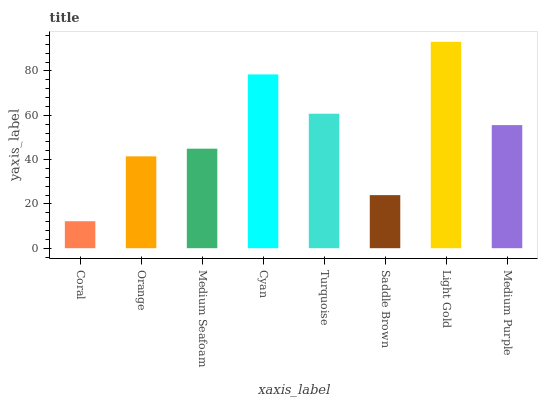Is Coral the minimum?
Answer yes or no. Yes. Is Light Gold the maximum?
Answer yes or no. Yes. Is Orange the minimum?
Answer yes or no. No. Is Orange the maximum?
Answer yes or no. No. Is Orange greater than Coral?
Answer yes or no. Yes. Is Coral less than Orange?
Answer yes or no. Yes. Is Coral greater than Orange?
Answer yes or no. No. Is Orange less than Coral?
Answer yes or no. No. Is Medium Purple the high median?
Answer yes or no. Yes. Is Medium Seafoam the low median?
Answer yes or no. Yes. Is Coral the high median?
Answer yes or no. No. Is Light Gold the low median?
Answer yes or no. No. 